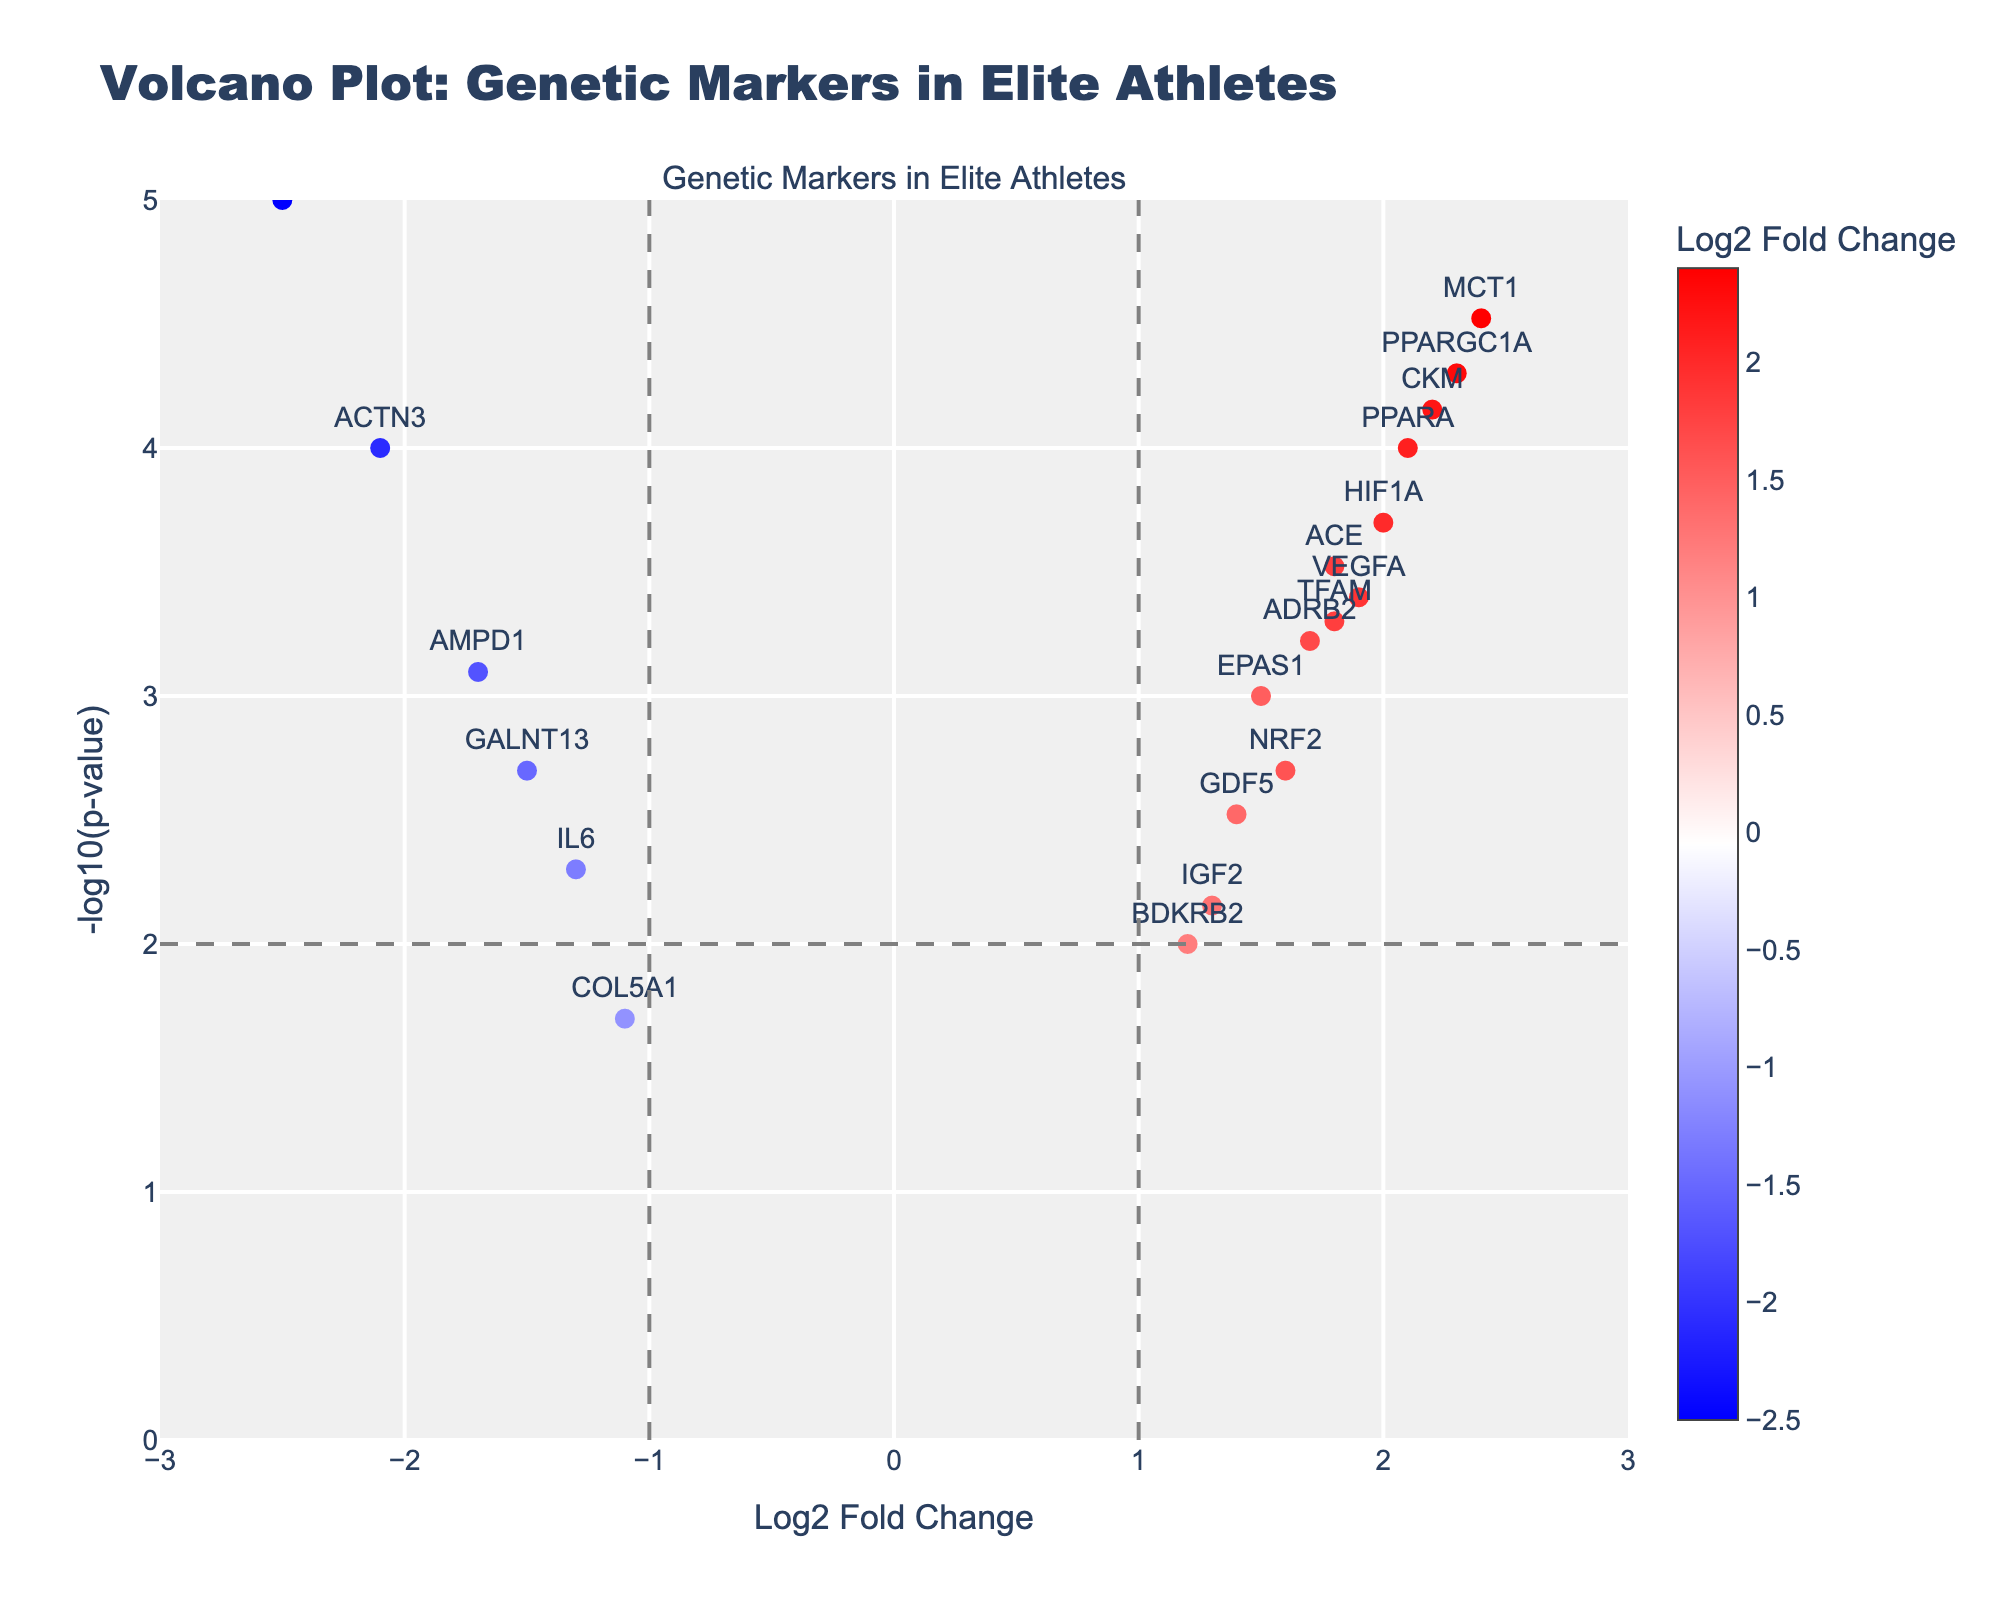What is the title of the volcano plot? The title is typically displayed at the top of the plot, as it is meant to provide a summary of what the data represents.
Answer: Volcano Plot: Genetic Markers in Elite Athletes What does the x-axis represent? The x-axis on a volcano plot usually represents the log2 fold change, indicating how much a gene's expression differs between two groups (elite athletes and average athletes, in this case).
Answer: Log2 Fold Change What value does the y-axis represent in the plot? The y-axis on a volcano plot represents the -log10(p-value), which indicates the statistical significance of the gene's expression difference.
Answer: -log10(p-value) Which gene has the highest log2 fold change? By looking at the point furthest to the right on the x-axis, we can see that the gene with the highest log2 fold change is annotated.
Answer: MCT1 Which gene shows the lowest p-value? The gene at the highest point on the y-axis indicates the lowest p-value, as -log10(p-value) is highest there, making the p-value itself smallest.
Answer: MSTN What is the relationship between ACTN3 and PPARGC1A in terms of log2 fold change and significance? By comparing the positions of ACTN3 and PPARGC1A on both axes, we can assess their log2 fold changes and p-values. ACTN3 has a negative log2 fold change, while PPARGC1A has a positive one. PPARGC1A is also positioned higher on the y-axis, indicating a more significant p-value.
Answer: ACTN3 has a negative log2 fold change and a less significant p-value compared to PPARGC1A How many genes demonstrate a negative log2 fold change? By counting the number of points on the left side of the center vertical axis (x = 0), we can find the number of genes with negative log2 fold changes.
Answer: 4 Which gene has a log2 fold change closest to zero but still significantly different? This can be determined by looking for a gene close to the x = 0 line but situated high on the y-axis, indicating significant p-value.
Answer: GALNT13 Which gene is the most downregulated and what is its p-value? The most downregulated gene will have the smallest (most negative) log2 fold change, and its corresponding p-value can be read from its position on the y-axis.
Answer: MSTN with p-value 0.00001 What is the log2 fold change and p-value of the gene CKM? By locating CKM on the plot, its log2 fold change and y-axis (p-value) can be directly read from its position and hover text.
Answer: Log2 fold change: 2.2, p-value: 0.00007 